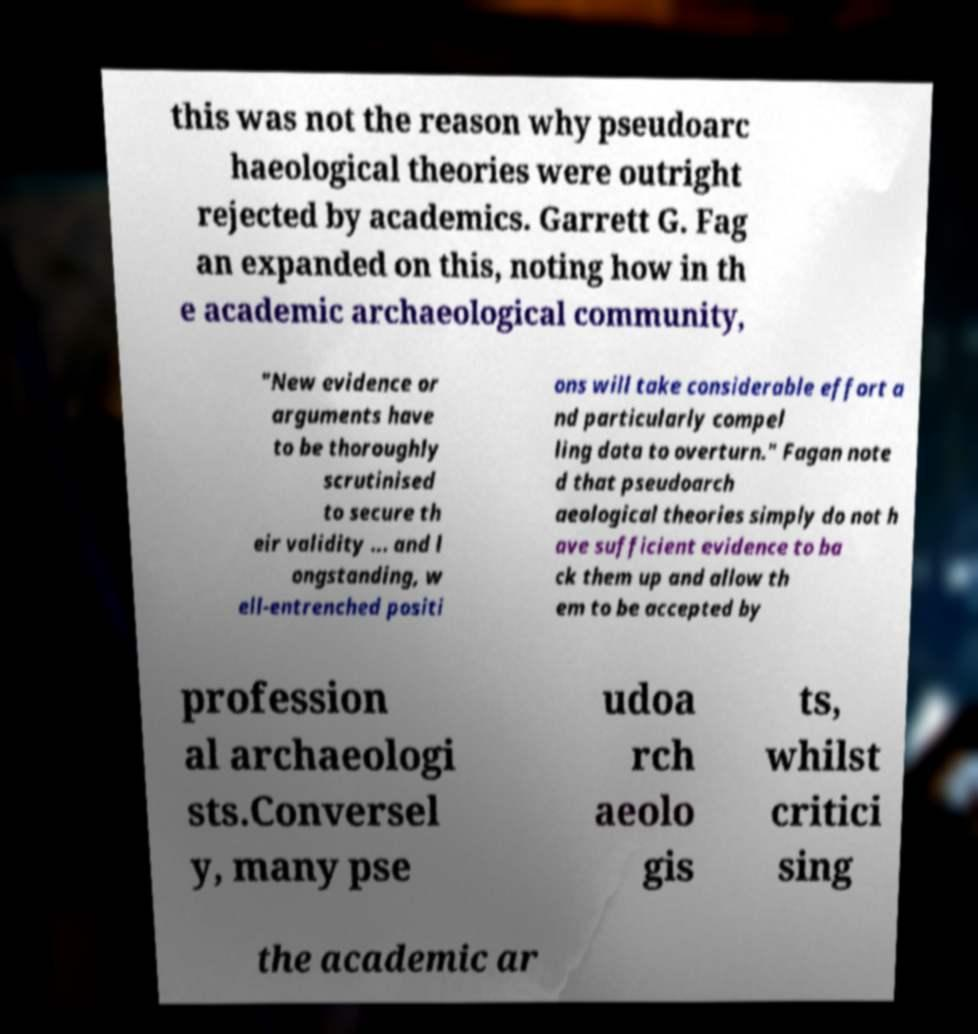Can you read and provide the text displayed in the image?This photo seems to have some interesting text. Can you extract and type it out for me? this was not the reason why pseudoarc haeological theories were outright rejected by academics. Garrett G. Fag an expanded on this, noting how in th e academic archaeological community, "New evidence or arguments have to be thoroughly scrutinised to secure th eir validity ... and l ongstanding, w ell-entrenched positi ons will take considerable effort a nd particularly compel ling data to overturn." Fagan note d that pseudoarch aeological theories simply do not h ave sufficient evidence to ba ck them up and allow th em to be accepted by profession al archaeologi sts.Conversel y, many pse udoa rch aeolo gis ts, whilst critici sing the academic ar 